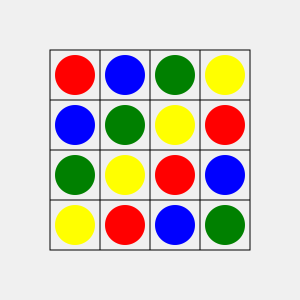In this 4x4 match-3 style puzzle grid, how many potential 3-in-a-row matches can be made with a single move (swapping adjacent gems)? To solve this problem, we need to examine the grid systematically:

1. Check for horizontal matches:
   - Row 1: No potential matches
   - Row 2: No potential matches
   - Row 3: Green-Yellow-Red can be matched by swapping the Green with the Blue above it
   - Row 4: No potential matches

2. Check for vertical matches:
   - Column 1: No potential matches
   - Column 2: No potential matches
   - Column 3: Blue-Red-Blue can be matched by swapping the Red with the Yellow to its left
   - Column 4: No potential matches

3. Check for L-shaped matches:
   - Top-left: Red-Blue-Blue can be matched by swapping the Red with the Green to its right
   - Top-right: Yellow-Red-Red can be matched by swapping the Yellow with the Blue to its left
   - Bottom-left: Yellow-Green-Green can be matched by swapping the Yellow with the Red to its right
   - Bottom-right: Green-Blue-Blue can be matched by swapping the Green with the Red to its left

In total, we have identified 6 potential 3-in-a-row matches that can be made with a single move.
Answer: 6 